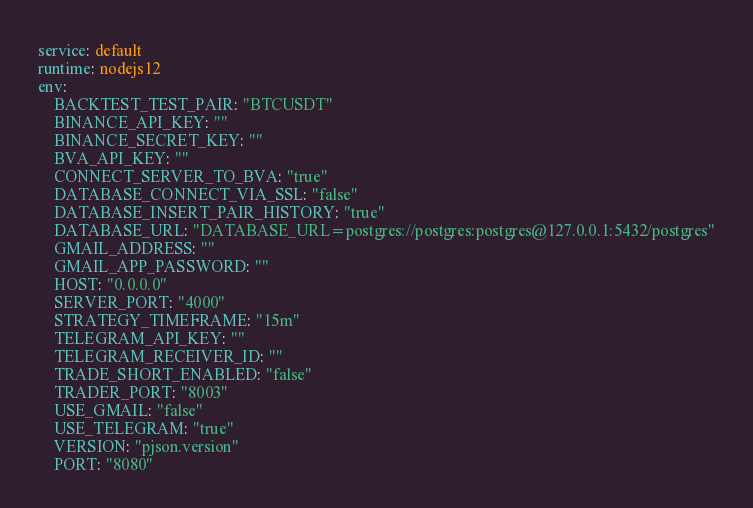<code> <loc_0><loc_0><loc_500><loc_500><_YAML_>service: default
runtime: nodejs12
env:
    BACKTEST_TEST_PAIR: "BTCUSDT"
    BINANCE_API_KEY: ""
    BINANCE_SECRET_KEY: ""
    BVA_API_KEY: ""
    CONNECT_SERVER_TO_BVA: "true"
    DATABASE_CONNECT_VIA_SSL: "false"
    DATABASE_INSERT_PAIR_HISTORY: "true"
    DATABASE_URL: "DATABASE_URL=postgres://postgres:postgres@127.0.0.1:5432/postgres"
    GMAIL_ADDRESS: ""
    GMAIL_APP_PASSWORD: ""
    HOST: "0.0.0.0"
    SERVER_PORT: "4000"
    STRATEGY_TIMEFRAME: "15m"
    TELEGRAM_API_KEY: ""
    TELEGRAM_RECEIVER_ID: ""
    TRADE_SHORT_ENABLED: "false"
    TRADER_PORT: "8003"
    USE_GMAIL: "false"
    USE_TELEGRAM: "true"
    VERSION: "pjson.version"
    PORT: "8080"</code> 